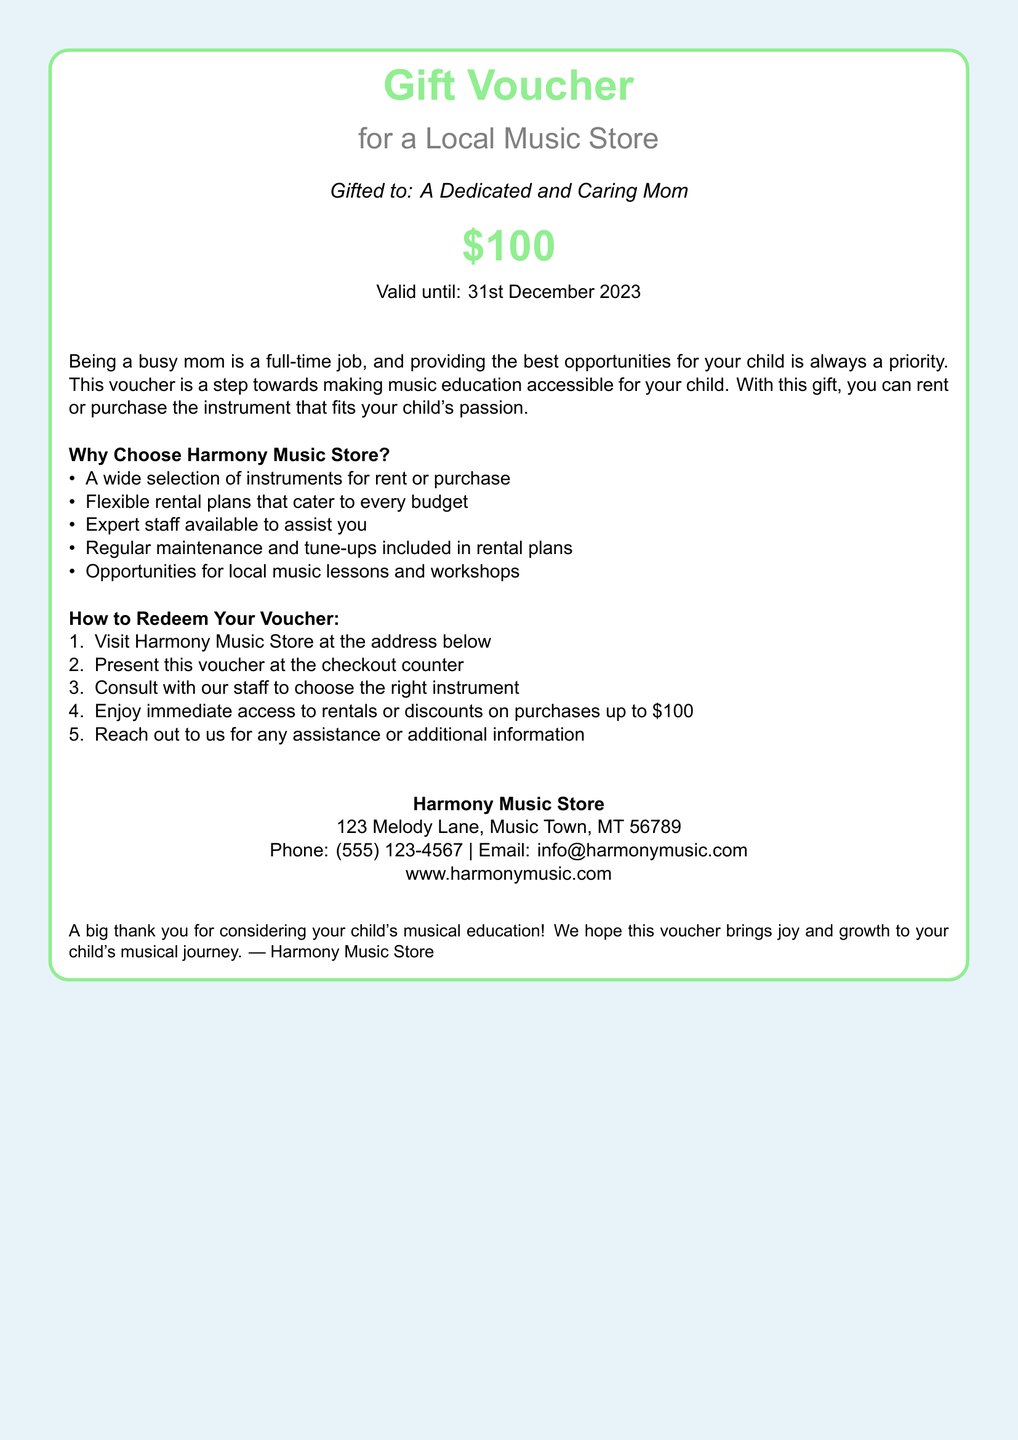what is the value of the gift voucher? The document states the voucher amount clearly as $100.
Answer: $100 what is the expiration date of the voucher? The voucher has a specific validity mentioned, which is 31st December 2023.
Answer: 31st December 2023 where can the voucher be used? The document specifies that it can be used at Harmony Music Store.
Answer: Harmony Music Store what address is provided for the music store? The address for the music store is listed in the document as 123 Melody Lane, Music Town, MT 56789.
Answer: 123 Melody Lane, Music Town, MT 56789 what type of services does Harmony Music Store offer? The document describes the services as a wide selection of instruments for rent or purchase and more.
Answer: instruments rental or purchase how can the voucher be redeemed? The document outlines a multiple-step process for redemption, starting with visiting the store.
Answer: Presenting it at the checkout what are two benefits of renting an instrument from Harmony Music Store? The document mentions expert staff assistance and regular maintenance as benefits of renting.
Answer: expert staff assistance, regular maintenance what is the phone number for Harmony Music Store? The document provides a contact number for inquiries, which is (555) 123-4567.
Answer: (555) 123-4567 who is the voucher gifted to? The document specifies that the voucher is gifted to "A Dedicated and Caring Mom".
Answer: A Dedicated and Caring Mom 